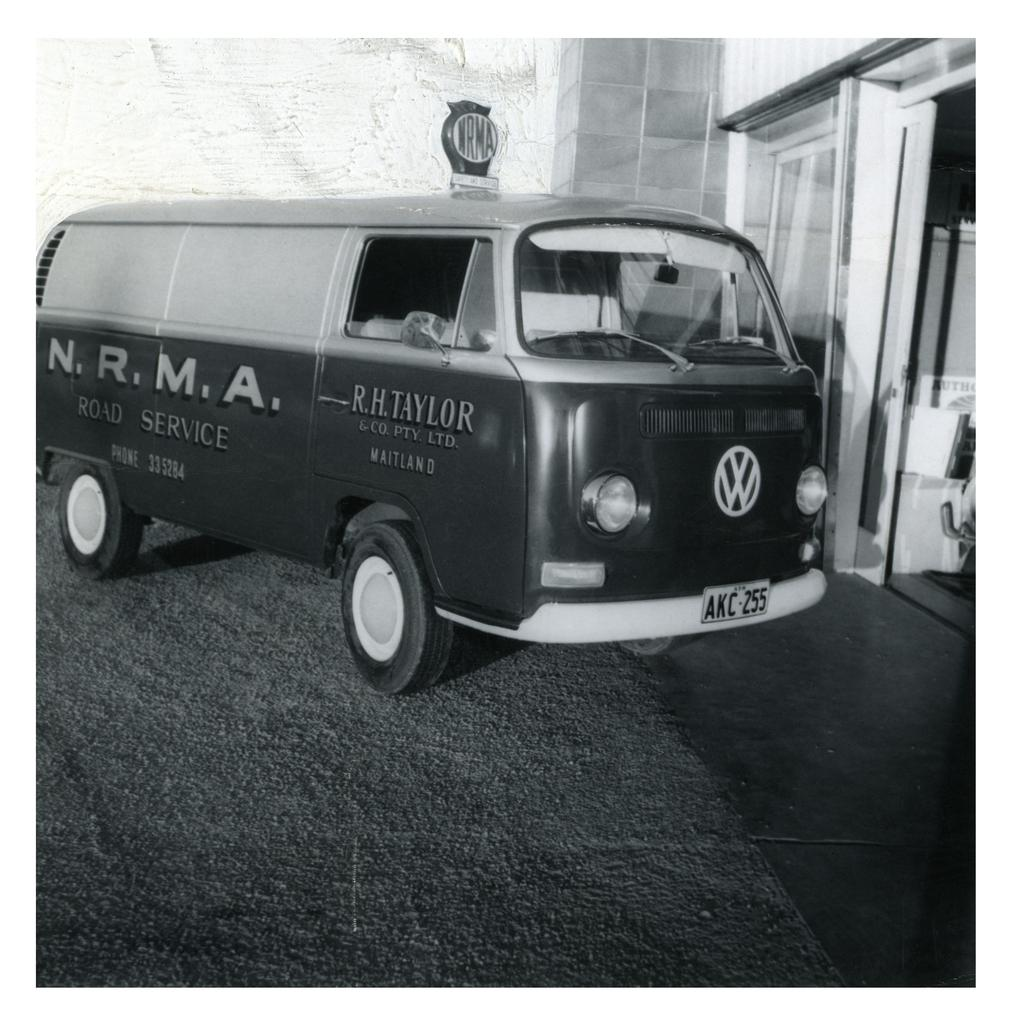<image>
Relay a brief, clear account of the picture shown. the vintage model van which has a writing in side as N.R.M.A road service 